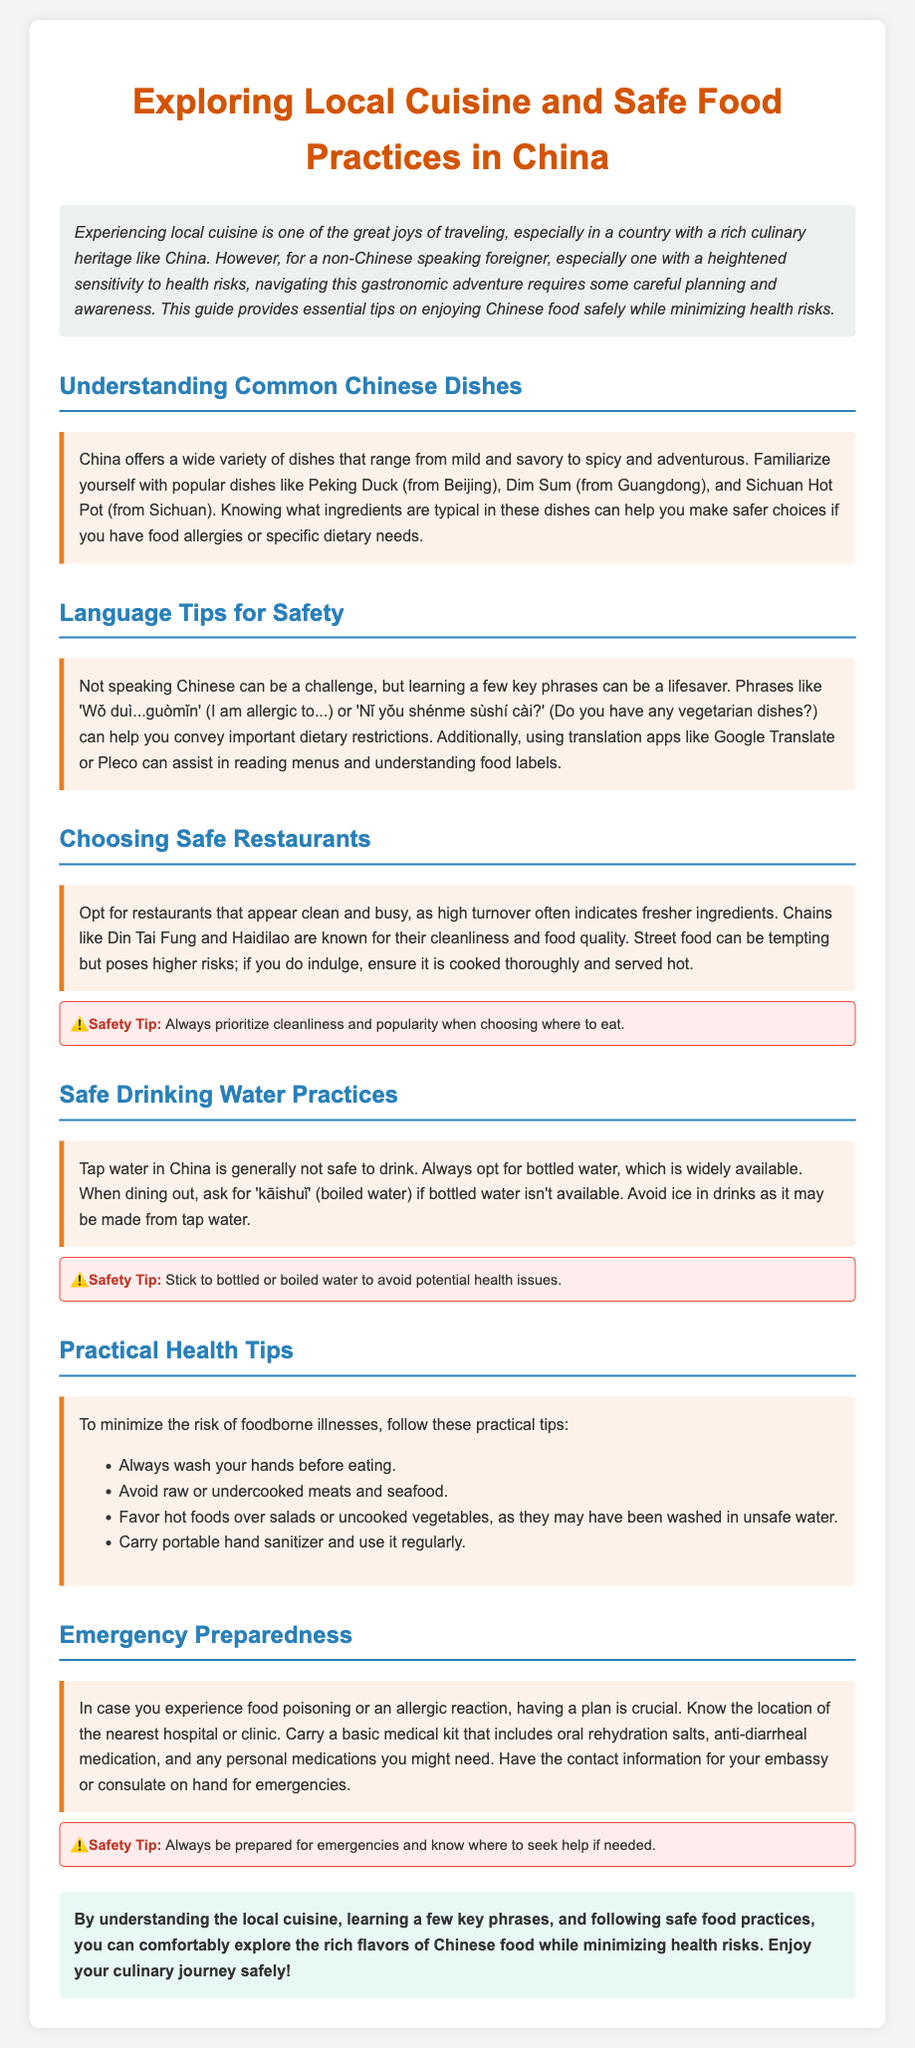What is the title of the guide? The title provided in the document describes the subject matter of the document regarding Chinese cuisine and safe food practices.
Answer: Exploring Local Cuisine and Safe Food Practices in China What are two popular dishes mentioned? The document lists some popular Chinese dishes, highlighting their cultural significance and location.
Answer: Peking Duck, Dim Sum What should you avoid drinking in China? The document advises on safe drinking practices, particularly regarding water sources.
Answer: Tap water What type of restaurants are suggested for safety? The guide recommends certain types of dining establishments based on hygiene and food quality.
Answer: Clean and busy restaurants Which phrase can help indicate a food allergy? The document provides essential phrases for non-Chinese speakers to communicate their dietary needs.
Answer: Wǒ duì...guòmǐn What should you have in your emergency kit? The section on emergency preparedness mentions specific items to include in a medical kit for safety.
Answer: Oral rehydration salts Why is high turnover important when choosing a restaurant? The document explains that the popularity of a restaurant can be an indicator of food freshness and safety.
Answer: Indicates fresher ingredients What should be favored over raw foods? The guide gives health tips on food choices to minimize the risk of foodborne illnesses.
Answer: Hot foods What is one way to ensure safe drinking water? The document explains practices for safe water consumption while dining in China.
Answer: Bottled water 